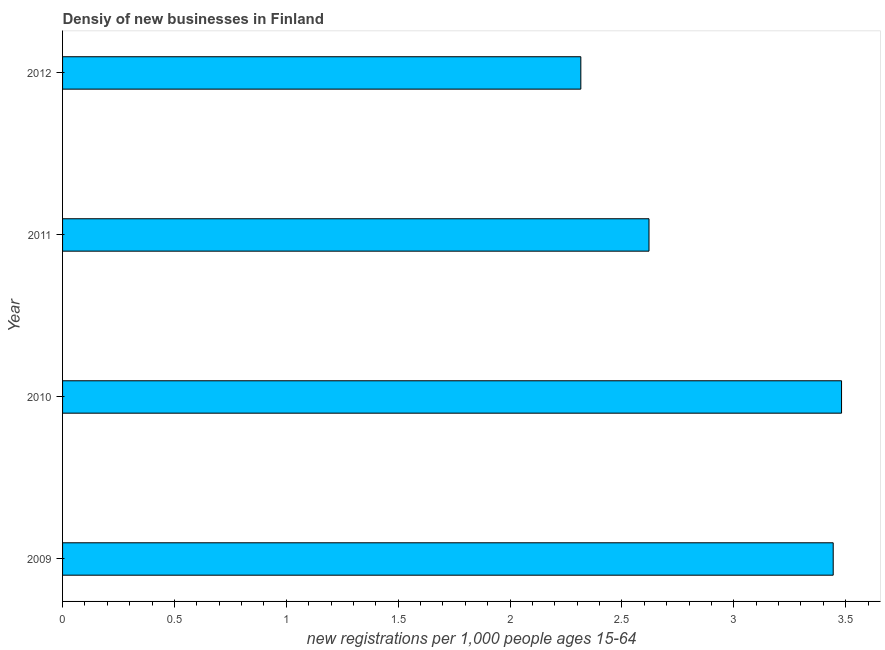Does the graph contain any zero values?
Provide a short and direct response. No. What is the title of the graph?
Give a very brief answer. Densiy of new businesses in Finland. What is the label or title of the X-axis?
Your answer should be compact. New registrations per 1,0 people ages 15-64. What is the label or title of the Y-axis?
Ensure brevity in your answer.  Year. What is the density of new business in 2010?
Ensure brevity in your answer.  3.48. Across all years, what is the maximum density of new business?
Provide a succinct answer. 3.48. Across all years, what is the minimum density of new business?
Keep it short and to the point. 2.32. What is the sum of the density of new business?
Make the answer very short. 11.86. What is the difference between the density of new business in 2010 and 2011?
Give a very brief answer. 0.86. What is the average density of new business per year?
Make the answer very short. 2.97. What is the median density of new business?
Give a very brief answer. 3.03. Do a majority of the years between 2011 and 2012 (inclusive) have density of new business greater than 1.5 ?
Your response must be concise. Yes. What is the ratio of the density of new business in 2009 to that in 2012?
Ensure brevity in your answer.  1.49. What is the difference between the highest and the second highest density of new business?
Your answer should be compact. 0.04. Is the sum of the density of new business in 2009 and 2011 greater than the maximum density of new business across all years?
Keep it short and to the point. Yes. What is the difference between the highest and the lowest density of new business?
Provide a short and direct response. 1.17. How many bars are there?
Your response must be concise. 4. How many years are there in the graph?
Provide a short and direct response. 4. Are the values on the major ticks of X-axis written in scientific E-notation?
Your response must be concise. No. What is the new registrations per 1,000 people ages 15-64 in 2009?
Your answer should be very brief. 3.44. What is the new registrations per 1,000 people ages 15-64 in 2010?
Provide a short and direct response. 3.48. What is the new registrations per 1,000 people ages 15-64 of 2011?
Provide a short and direct response. 2.62. What is the new registrations per 1,000 people ages 15-64 in 2012?
Provide a short and direct response. 2.32. What is the difference between the new registrations per 1,000 people ages 15-64 in 2009 and 2010?
Your response must be concise. -0.04. What is the difference between the new registrations per 1,000 people ages 15-64 in 2009 and 2011?
Make the answer very short. 0.82. What is the difference between the new registrations per 1,000 people ages 15-64 in 2009 and 2012?
Make the answer very short. 1.13. What is the difference between the new registrations per 1,000 people ages 15-64 in 2010 and 2011?
Keep it short and to the point. 0.86. What is the difference between the new registrations per 1,000 people ages 15-64 in 2010 and 2012?
Offer a terse response. 1.17. What is the difference between the new registrations per 1,000 people ages 15-64 in 2011 and 2012?
Your response must be concise. 0.3. What is the ratio of the new registrations per 1,000 people ages 15-64 in 2009 to that in 2011?
Ensure brevity in your answer.  1.31. What is the ratio of the new registrations per 1,000 people ages 15-64 in 2009 to that in 2012?
Make the answer very short. 1.49. What is the ratio of the new registrations per 1,000 people ages 15-64 in 2010 to that in 2011?
Keep it short and to the point. 1.33. What is the ratio of the new registrations per 1,000 people ages 15-64 in 2010 to that in 2012?
Make the answer very short. 1.5. What is the ratio of the new registrations per 1,000 people ages 15-64 in 2011 to that in 2012?
Your answer should be compact. 1.13. 